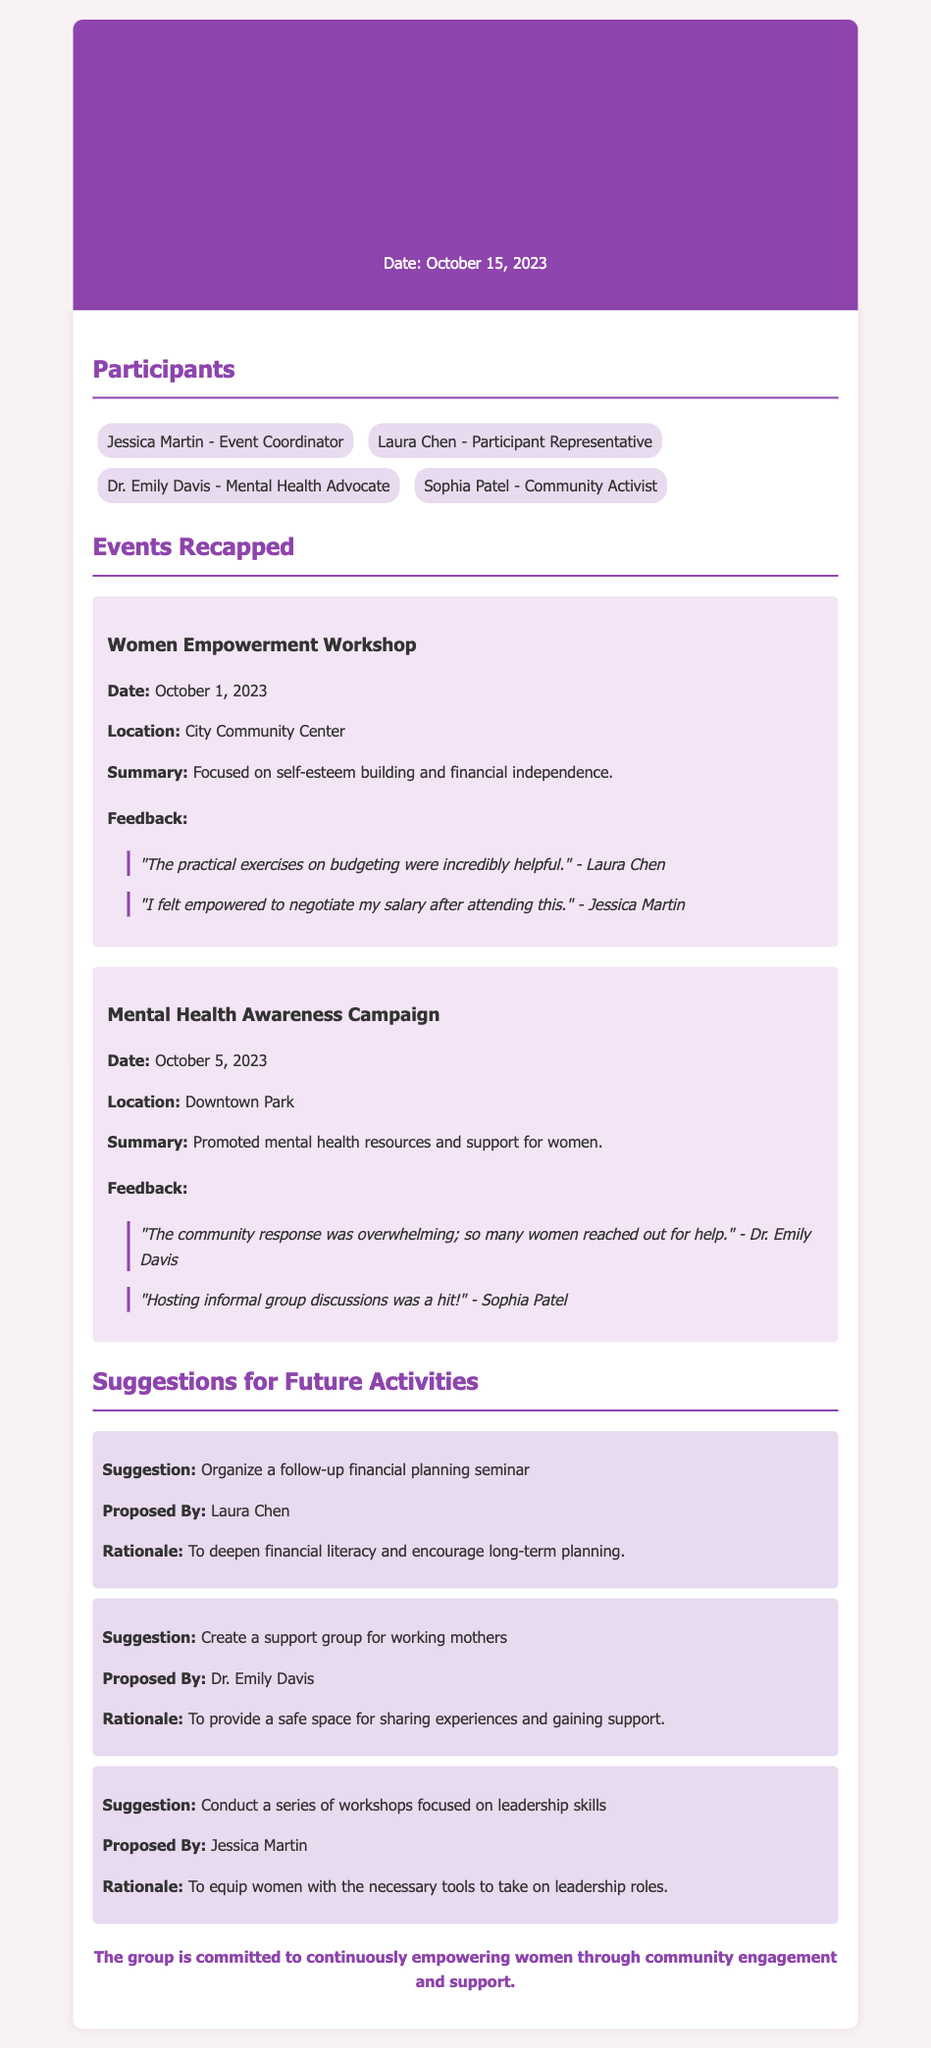What was the date of the Women Empowerment Workshop? The document specifies the date of the Women Empowerment Workshop under "Events Recapped" section.
Answer: October 1, 2023 Who proposed the suggestion to create a support group for working mothers? The suggestion under "Suggestions for Future Activities" indicates who proposed each activity.
Answer: Dr. Emily Davis What was the location of the Mental Health Awareness Campaign? The location is mentioned in the summary of the campaign under "Events Recapped".
Answer: Downtown Park What feedback did Laura Chen provide for the Women Empowerment Workshop? Feedback from participants is detailed under each event in the "Feedback" section.
Answer: "The practical exercises on budgeting were incredibly helpful." How many participants were mentioned in the meeting minutes? The number of participants is listed under the "Participants" section in the document.
Answer: Four What suggestion did Jessica Martin propose for future activities? The suggestions for future activities include the proponent's name, which can be found in the "Suggestions for Future Activities" section.
Answer: Conduct a series of workshops focused on leadership skills What was the main focus of the recent events discussed? The purpose of the meeting is highlighted in the title and introductory section of the document.
Answer: Empowering women What was the rationale given for organizing a follow-up financial planning seminar? Each suggestion includes a rationale in the document, clarifying the reasoning behind it.
Answer: To deepen financial literacy and encourage long-term planning 